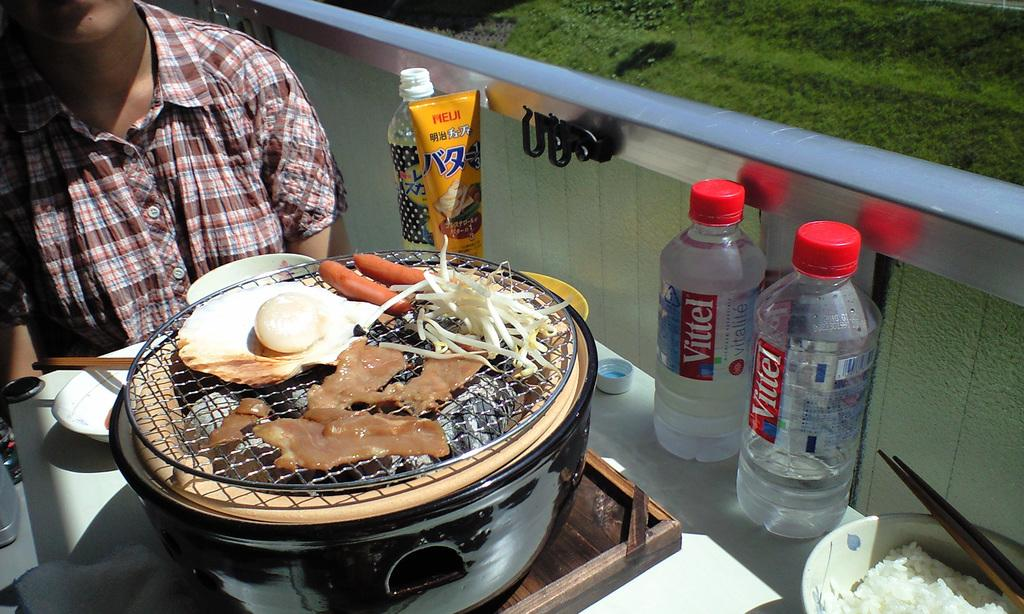<image>
Render a clear and concise summary of the photo. Two Vittel waters sit next to some cooking food 